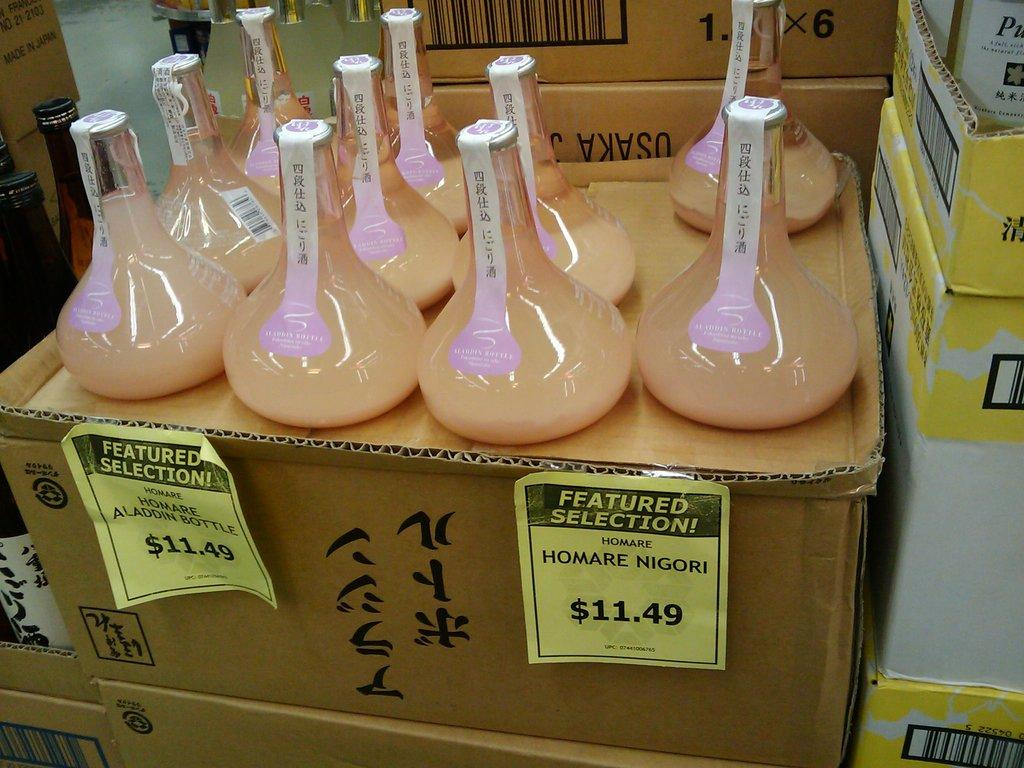<image>
Offer a succinct explanation of the picture presented. a bunch of flasks on top of a box that has a label on it that says 'featured selection!' 